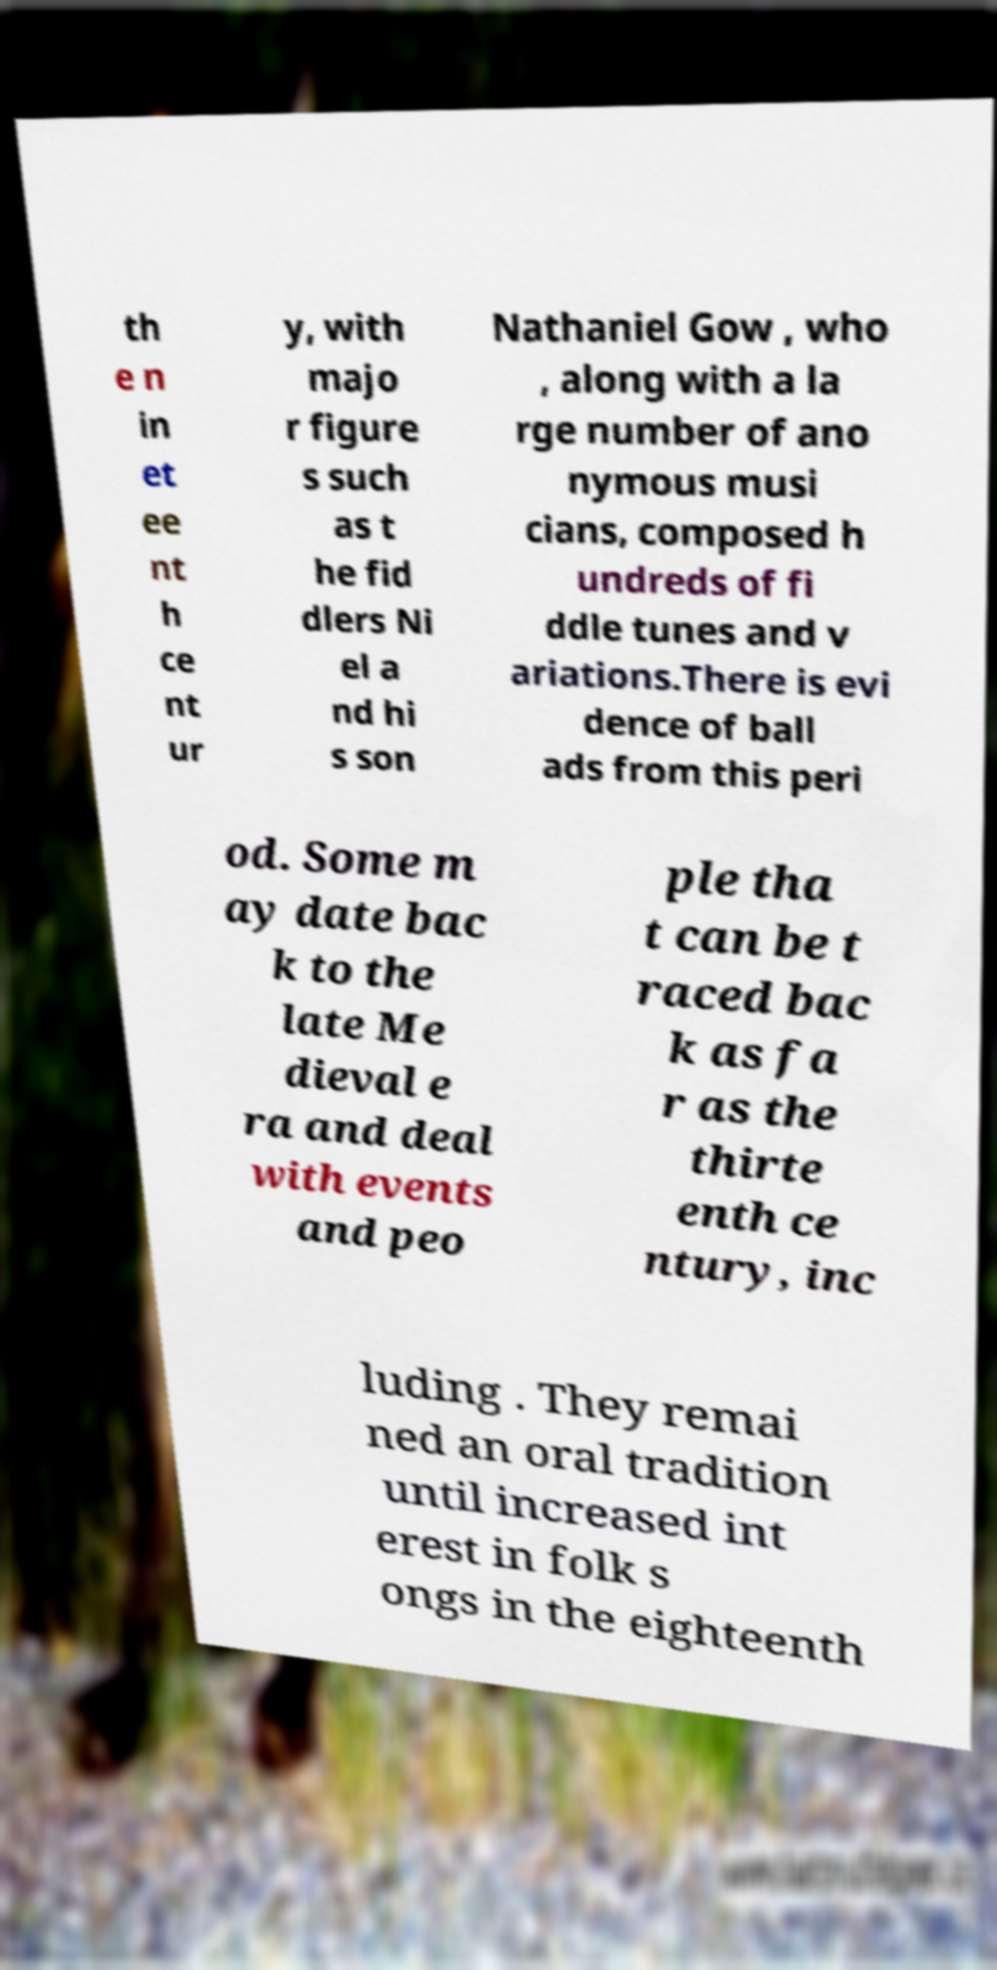Can you accurately transcribe the text from the provided image for me? th e n in et ee nt h ce nt ur y, with majo r figure s such as t he fid dlers Ni el a nd hi s son Nathaniel Gow , who , along with a la rge number of ano nymous musi cians, composed h undreds of fi ddle tunes and v ariations.There is evi dence of ball ads from this peri od. Some m ay date bac k to the late Me dieval e ra and deal with events and peo ple tha t can be t raced bac k as fa r as the thirte enth ce ntury, inc luding . They remai ned an oral tradition until increased int erest in folk s ongs in the eighteenth 